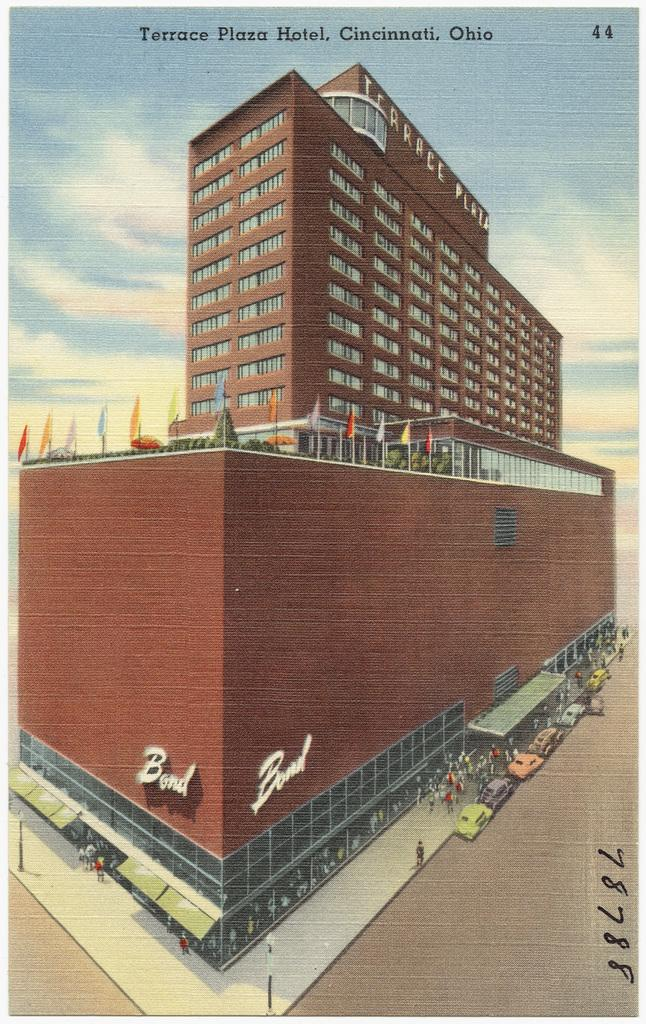What type of structure is present in the image? There is a building in the image. Can you describe the people in the image? There are people in the image. What else can be seen on the ground in the image? There are vehicles on the ground in the image. What feature of the building is visible in the image? There are windows visible in the image. What additional objects can be seen in the image? There are flags and poles in the image. What type of vegetation is present in the image? There are trees and plants in the image. What can be seen in the background of the image? The sky is visible in the background of the image. What type of breakfast is being served in the image? There is no breakfast present in the image. What kind of bait is being used by the father in the image? There is no father or bait present in the image. 